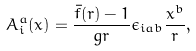<formula> <loc_0><loc_0><loc_500><loc_500>A _ { i } ^ { a } ( x ) = \frac { \bar { f } ( r ) - 1 } { g r } \epsilon _ { i a b } \frac { x ^ { b } } { r } ,</formula> 